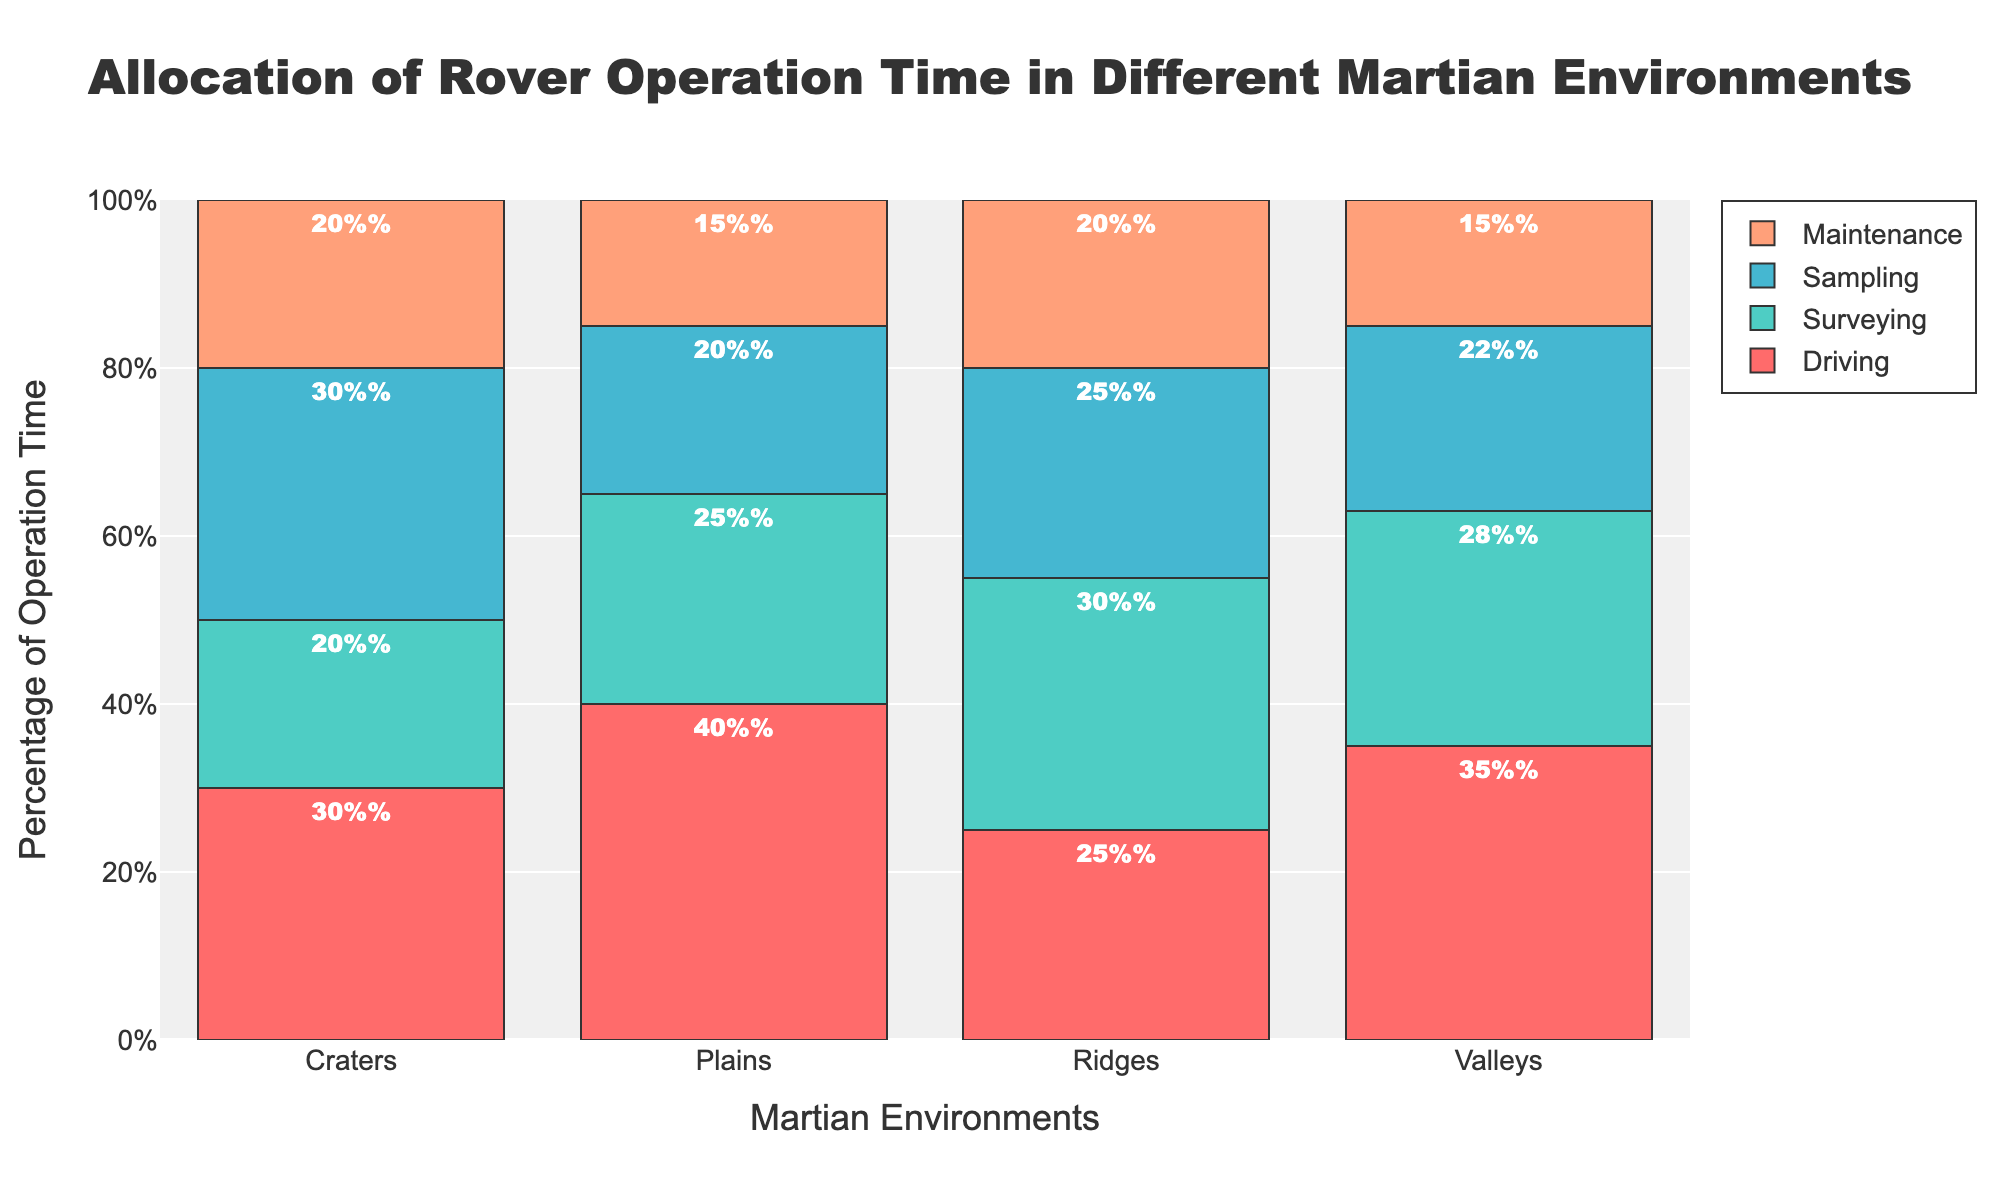How many Martian environments are evaluated in the plot? The x-axis displays the labels for the different environments under evaluation. By counting these labels, we can determine the total number of environments examined in the chart.
Answer: 4 Which environment has the highest percentage of time allocated to Driving? By observing the heights of the sections in the 100% stacked area chart for the Driving category, you can determine the environment with the highest percentage by comparing the different segments.
Answer: Plains What is the percentage difference in Sampling time between Craters and Valleys? The plot shows the percentages for each activity in each environment. The Sampling percentages for Craters and Valleys are 30% and 22% respectively. Subtracting these values gives the difference.
Answer: 8% Which activity has the least variance in operation time across environments? Inspecting the plot, compare the lengths of the sections for each activity category spread over the different environments. The category with the most uniformly sized sections has the least variance.
Answer: Maintenance Is there any environment where Surveying operation time is higher than Driving operation time? For each environment, compare the heights of the sections in the plot representing Surveying and Driving. Check if Surveying surpasses Driving anywhere.
Answer: Ridges What’s the average percentage allocated to Maintenance among all environments? Sum the percentage values for Maintenance in all environments and divide by the number of environments. These values are: 20%, 15%, 20%, and 15%, which sum up to 70%. Divide by 4 to get the average.
Answer: 17.5% Which environment shows the most balanced allocation of operation time? By evaluating the heights of the different sections for each environment, identify the one where the sections are most equal in size, signaling a more balanced allocation.
Answer: Craters In which environment is the total percentage for Sampling and Driving combined the highest? Add the percentages for Sampling and Driving in each environment and compare these sums. The sums are: Craters (30% + 30%), Plains (20% + 40%), Ridges (25% + 25%), Valleys (22% + 35%).
Answer: Craters Is there any environment where the sum of Driving and Maintenance percentages equals 55%? For each environment, add the percentages for Driving and Maintenance to see if any sums match 55%. The sums are: Craters (50%), Plains (55%), Ridges (45%), Valleys (50%).
Answer: Plains 